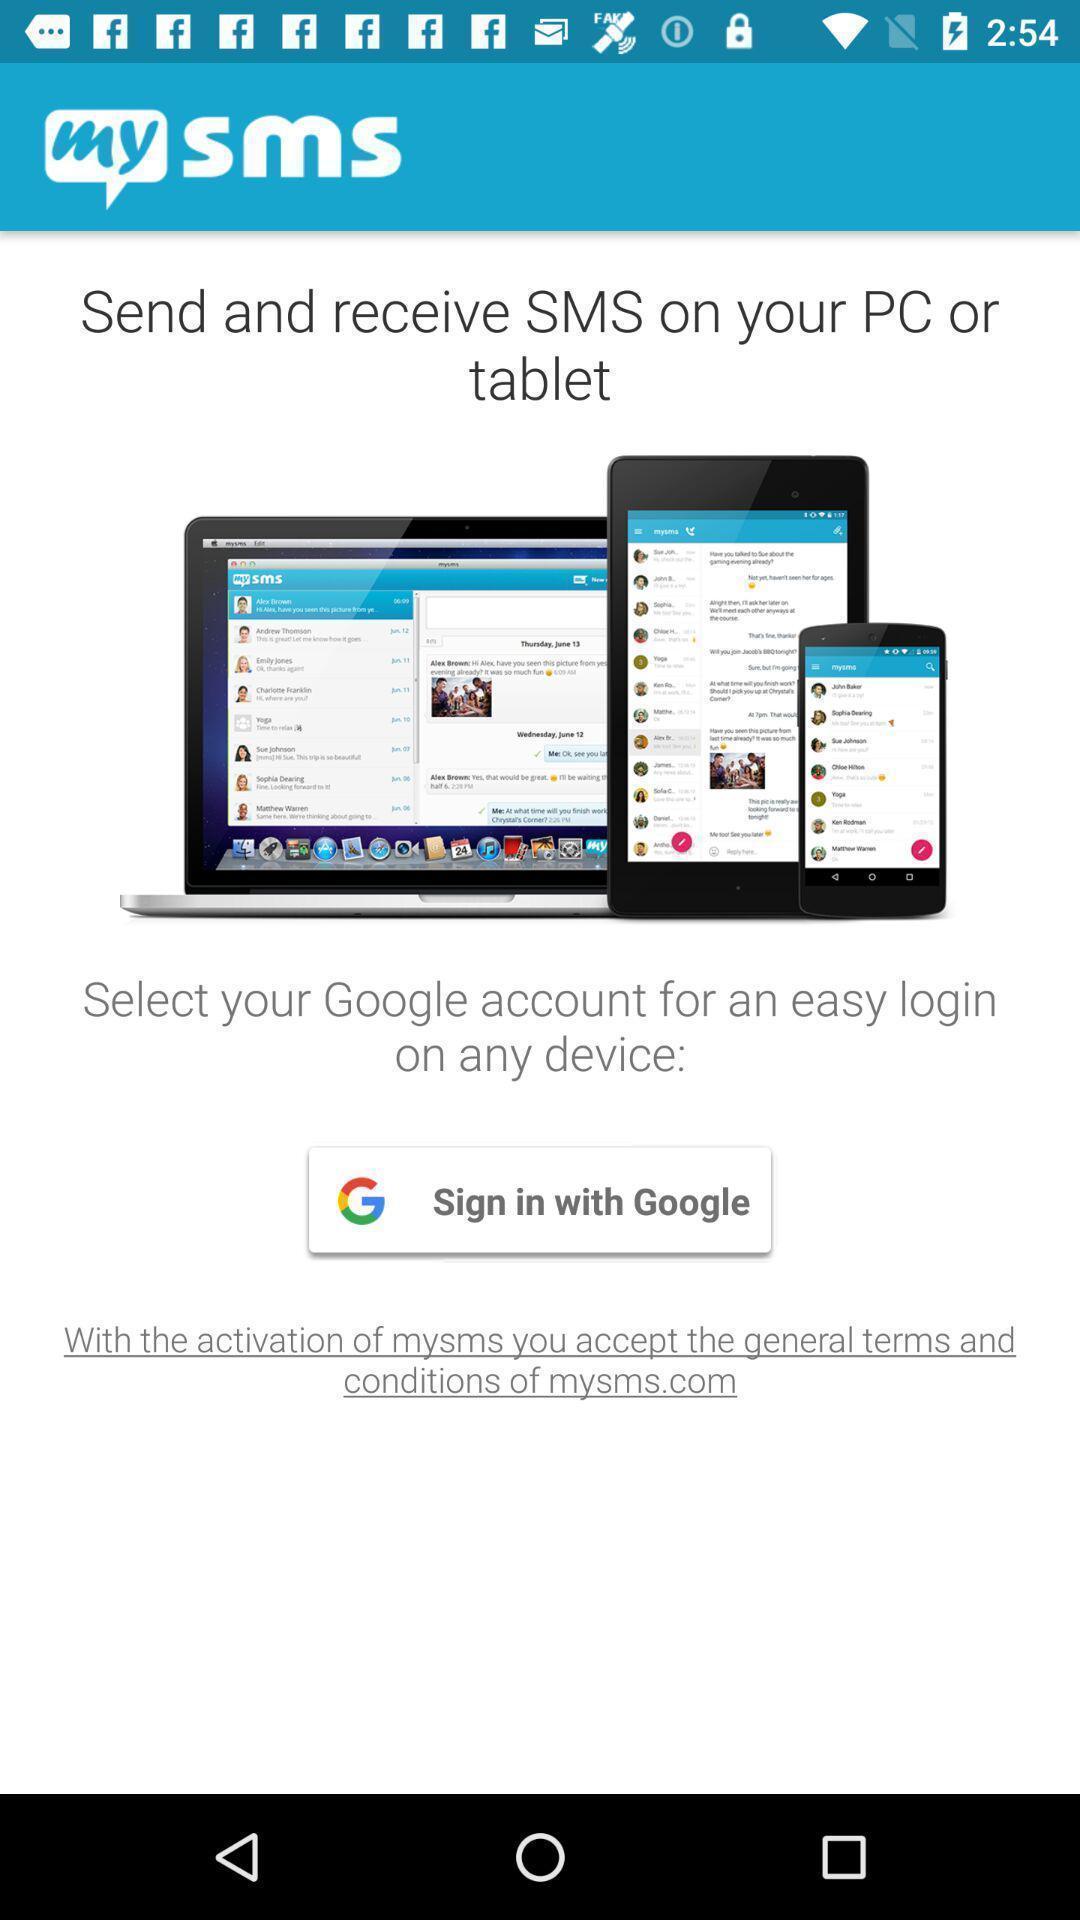Explain what's happening in this screen capture. Sign in page of chatting app. 